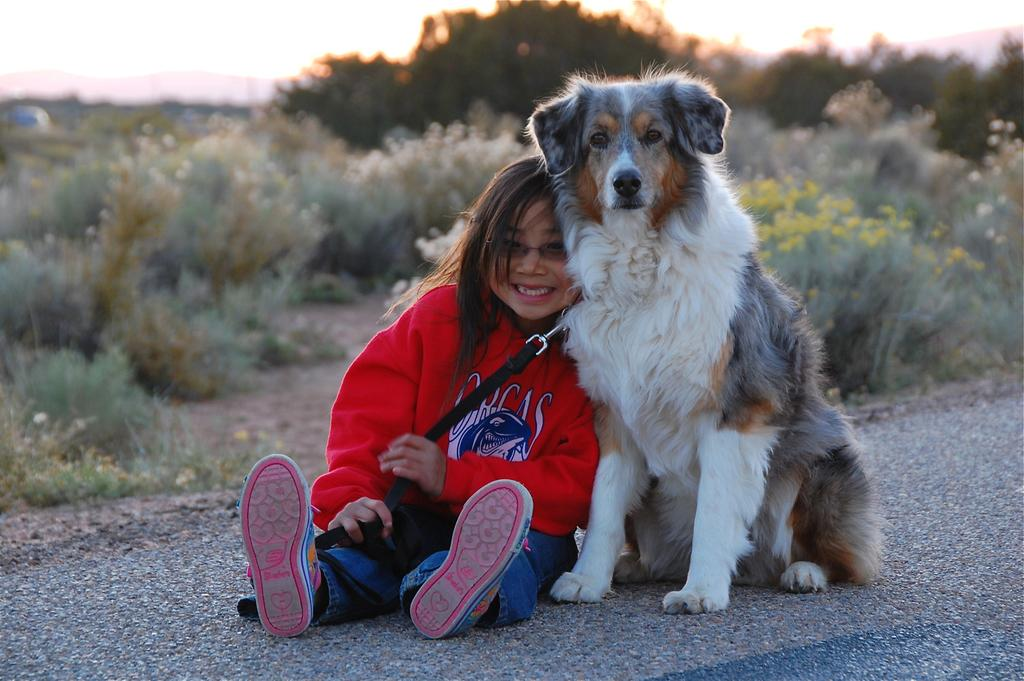Where was the image taken? The image was taken on a road. What is the girl doing in the image? The small girl is lying on a white dog. What can be seen in the background of the image? There are trees in the background of the image. What type of mine is visible in the image? There is no mine present in the image; it is taken on a road with a girl lying on a white dog and trees in the background. 